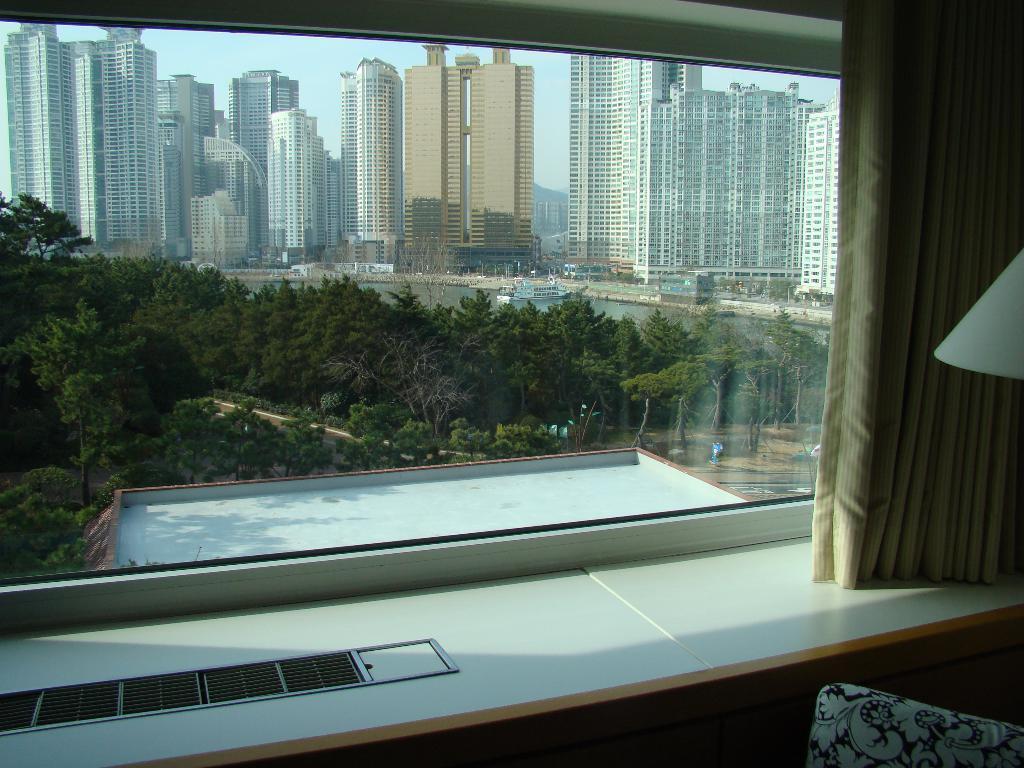Please provide a concise description of this image. In this image, we can see a glass window, curtains, table. Right side of the image, we can see white color and flower print cloth. Through the glass we can see the outside view. Here there are so many trees, buildings, water and sky. 